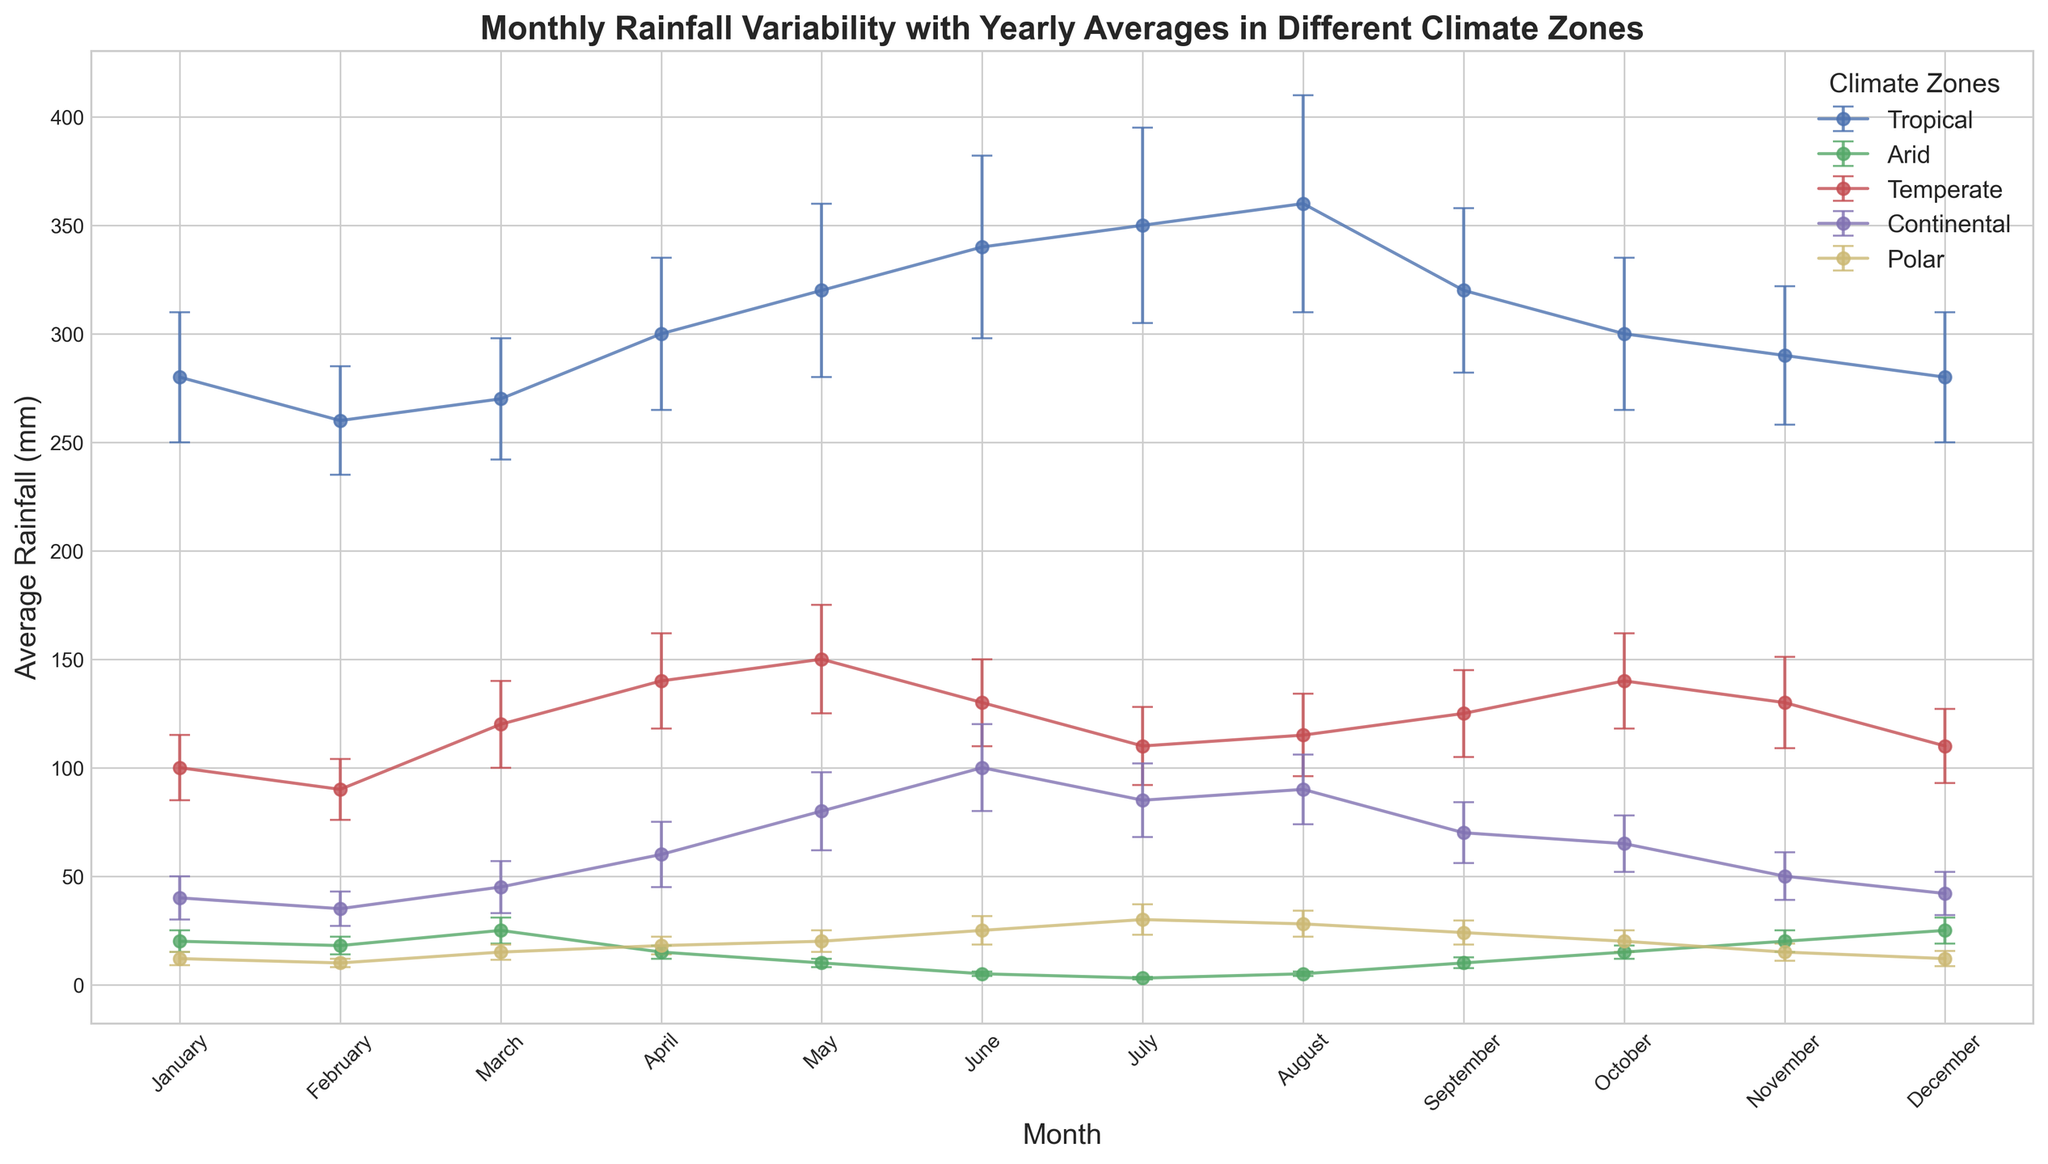Which month has the highest average rainfall in the Tropical climate zone? To find the month with the highest average rainfall for the Tropical climate zone, locate the curve for the Tropical climate zone, and identify the peak point. The highest point on the chart for this zone is in August.
Answer: August In which month does the Arid climate zone have the lowest rainfall, and what is that amount? Identify the lowest point on the Arid climate zone curve to find the month with the lowest rainfall. The lowest rainfall occurs in July, and the average amount is 3 mm.
Answer: July, 3 mm What is the difference in average rainfall between the wettest and driest months in the Temperate climate zone? First, identify the wettest month in the Temperate climate zone, which is May with 150 mm. Then, find the driest month, which is February with 90 mm. The difference is 150 mm - 90 mm = 60 mm.
Answer: 60 mm Which climate zone has the most stable rainfall throughout the year, judging by the error bars? The shortness and consistency of the error bars indicate stability in rainfall. Arid climate zone has the smallest error bars and shows little variation in rainfall throughout the year.
Answer: Arid In which month does the Continental climate zone experience rainfall similar to the lowest rainfall in the Temperate climate zone, and what is the average amount for both? The lowest rainfall in the Temperate climate zone is 90 mm in February. Locate a similar value in the Continental climate zone, which is in June and July, both around 85-100 mm. The average for February in Temperate is 90 mm, while in June and July, it's about 100 mm and 85 mm respectively for Continental.
Answer: June, 100 mm What is the average rainfall of the Tropical climate zone for the first six months of the year? Find the average rainfall for each of the first six months (January to June) in the Tropical zone, and then calculate the mean. The values are 280, 260, 270, 300, 320, and 340. The average is (280 + 260 + 270 + 300 + 320 + 340) / 6 = 295 mm.
Answer: 295 mm During which month does the Polar climate zone receive exactly the same amount of rainfall as the August average in the Arid climate zone? First, identify the average rainfall in August for the Arid climate zone (5 mm). Then, find a month in the Polar climate zone with the same amount, which is June.
Answer: June How does the average rainfall in July compare between the Polar and Continental climate zones? Identify the average rainfall for July in both zones from the chart. Polar has 30 mm, while Continental has 85 mm. Continental has higher rainfall.
Answer: Continental is higher Which climate zone exhibits the most variability in rainfall, considering the error bars? The larger the error bars, the higher the rainfall variability. The Tropical climate zone has the largest and most variable error bars, indicating higher variability.
Answer: Tropical What is the range of average rainfall values in the Polar climate zone throughout the year? Identify the maximum and minimum average rainfall values in the Polar climate zone. The highest is in July (30 mm) and the lowest is in February (10 mm). The range is 30 mm - 10 mm = 20 mm.
Answer: 20 mm 